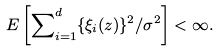<formula> <loc_0><loc_0><loc_500><loc_500>E \left [ \sum \nolimits _ { i = 1 } ^ { d } \{ \xi _ { i } ( z ) \} ^ { 2 } / \sigma ^ { 2 } \right ] < \infty .</formula> 